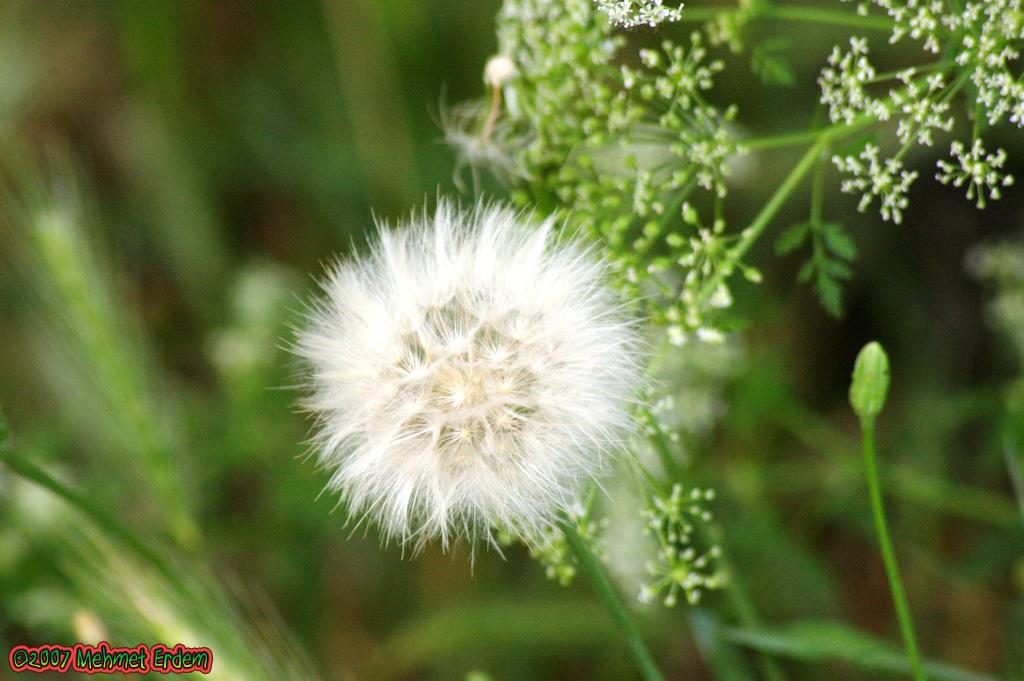What type of living organisms can be seen in the image? There are flowers on a plant in the image. Can you describe the plant in the image? The plant has flowers on it. What type of bread can be seen in the image? There is no bread present in the image; it features a plant with flowers. How many kittens are playing with the screw in the image? There are no kittens or screws present in the image. 